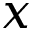<formula> <loc_0><loc_0><loc_500><loc_500>x</formula> 